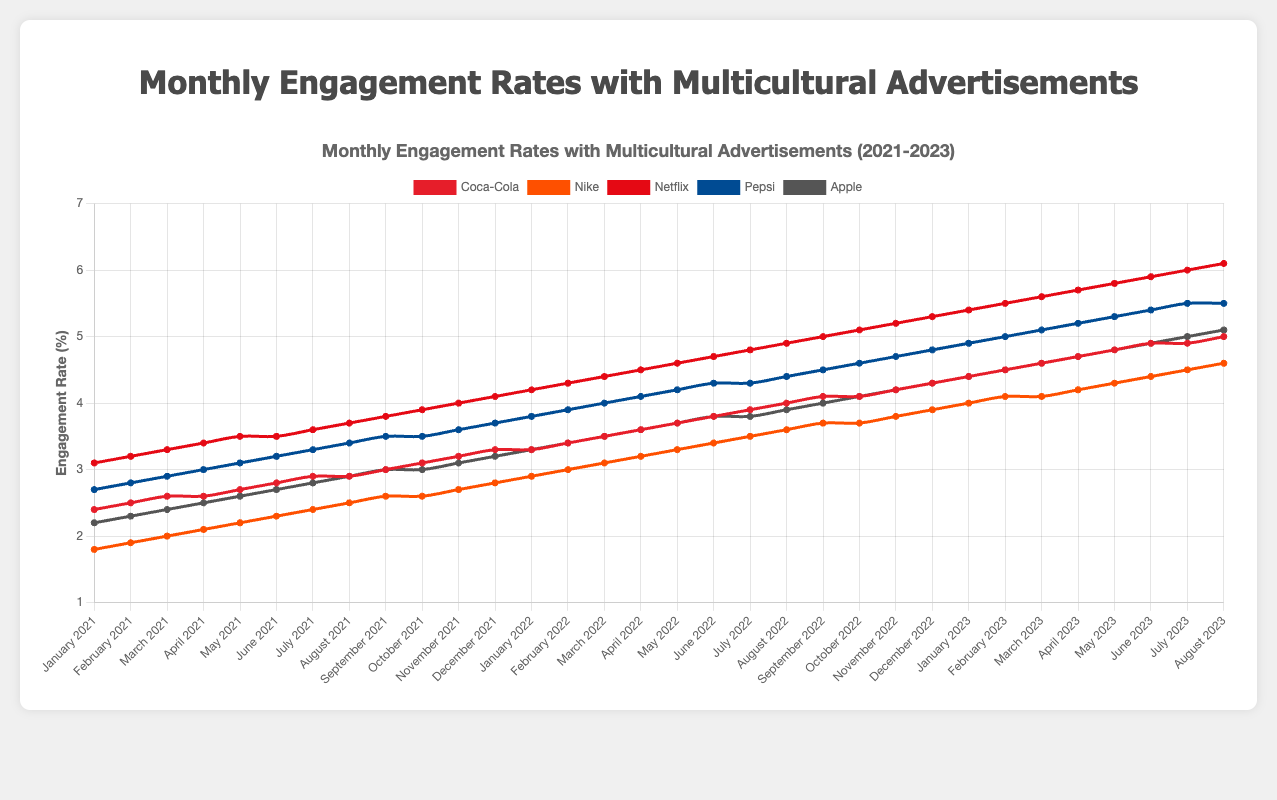What is the engagement rate of Coca-Cola in August 2022? To find the engagement rate of Coca-Cola in August 2022, locate the August 2022 data point within the Coca-Cola line. According to the data, the engagement rate is 4.0%.
Answer: 4.0% By how much did Netflix's engagement rate increase between January 2021 and January 2023? Refer to the Netflix engagement rate in January 2021 and January 2023. The rate in January 2021 is 3.1%, and the rate in January 2023 is 5.4%. The increase is 5.4% - 3.1% = 2.3%.
Answer: 2.3% Which company had the highest engagement rate in January 2021? In the figures for January 2021, compare the engagement rates of all companies. Netflix has the highest engagement rate of 3.1%.
Answer: Netflix What is the average engagement rate of Pepsi in 2023 up to August? Add the engagement rates of Pepsi for each month from January 2023 to August 2023: 4.9 + 5.0 + 5.1 + 5.2 + 5.3 + 5.4 + 5.5 ≈ 36.4. Divide by the number of months (8): 36.4 / 8 = 4.55.
Answer: 4.55 Which company’s engagement rate has the steepest upward trend from 2021 to 2023 overall? Analyze the slopes of the lines representing each company’s engagement rate from 2021 to 2023. Netflix shows the steepest increase from about 3.1% in January 2021 to 6.1% in August 2023.
Answer: Netflix During which month of 2023 did Apple reach an engagement rate of 5.0%? Look for the point where the Apple line intersects the 5.0% engagement rate in 2023. It occurs in July 2023.
Answer: July 2023 How did the engagement rate for Nike differ between June 2022 and June 2023? Compare Nike’s engagement rate in June 2022 (3.4%) to June 2023 (4.4%). The difference is 4.4% - 3.4% = 1.0%.
Answer: 1.0% What is the overall trend in the engagement rates of Pepsi from January 2021 to August 2023? Observe the Pepsi's engagement line, which shows a consistent upward trend from about 2.7% in January 2021 to 5.5% in August 2023.
Answer: Upward Considering the dataset, which brand had the least engagement rate fluctuation over the observed period? By examining the consistency of each line, Apple's engagement rate changes the least, with smaller increments compared to others, indicating less fluctuation.
Answer: Apple 